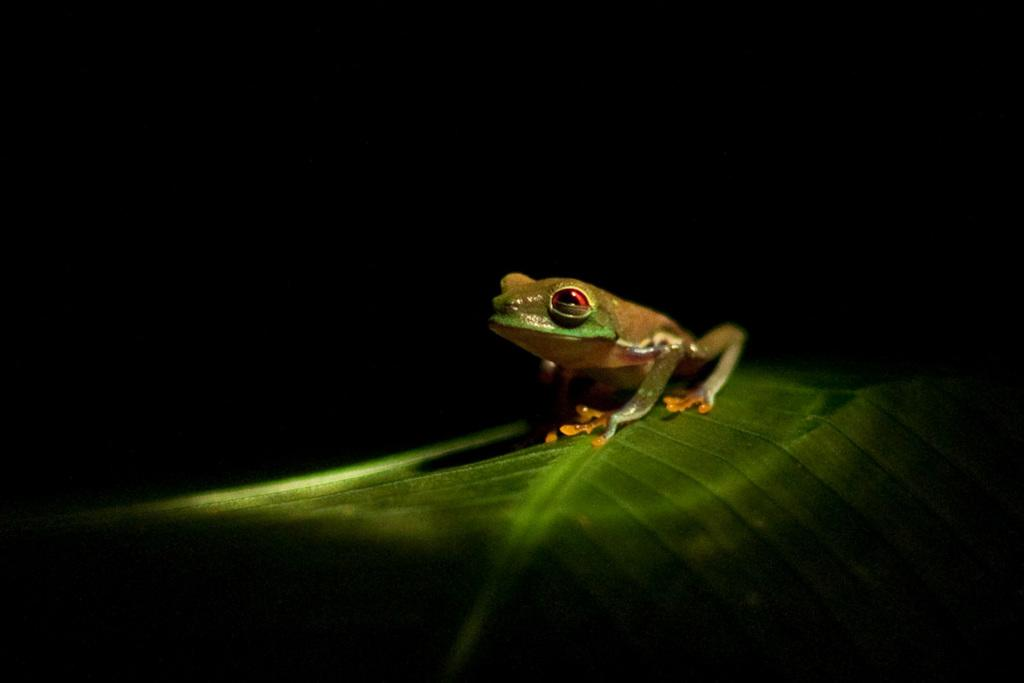What animal is present in the image? There is a frog in the image. Where is the frog located? The frog is on a leaf. What color is the background of the image? The background of the image is black. Is the frog sinking in quicksand in the image? There is no quicksand present in the image, and the frog is on a leaf. Does the frog have a quill in the image? Frogs do not have quills, and there is no indication of any quill in the image. 